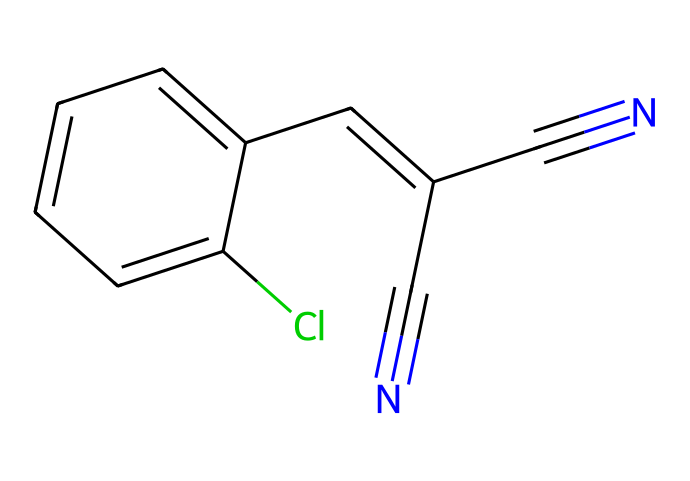What is the main functional group present in the chemical? Examining the structural formula shows the presence of a nitrile group, indicated by the C#N notation. This reveals the bond between carbon and nitrogen within a triple bond.
Answer: nitrile How many rings are present in the chemical structure? The structure reveals one aromatic ring (indicated by the alternating double bonds), confirming it as a monocyclic compound.
Answer: one What is the total number of carbon atoms in this chemical? Analyzing the SMILES representation, I count a total of 8 carbon atoms visible within the structure, including those in the rings and chains.
Answer: eight What is the total number of nitrogen atoms in the chemical? From the structure, I see there are 2 nitrogen atoms, as shown by the two occurrences of "N" in the formula.
Answer: two Is this chemical likely to be nonpolar or polar? The presence of polar functional groups (like the two nitrile groups) along with the aromatic ring suggests that this compound has polar characteristics, making it more soluble in polar solvents.
Answer: polar What kind of reactions might this chemical undergo due to its functional groups? The nitrile group indicates that this compound can undergo hydrolysis, reduction, or nucleophilic addition, typical for compounds with nitriles, allowing a variety of synthetic pathways.
Answer: hydrolysis 